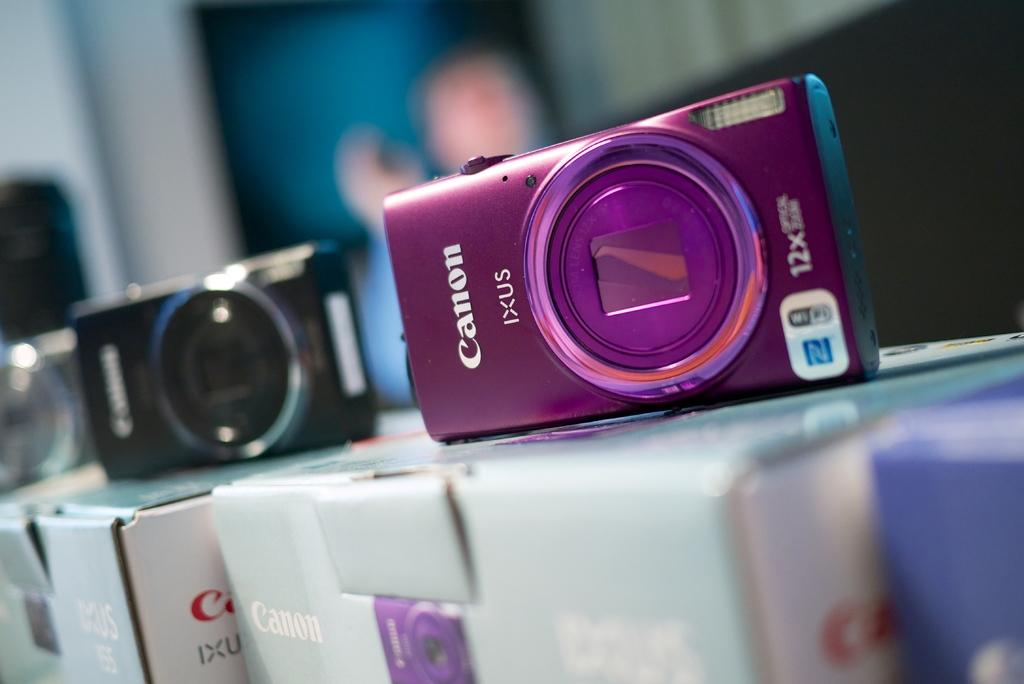<image>
Share a concise interpretation of the image provided. Three canon 12 X cameras on display on top of their boxes. 